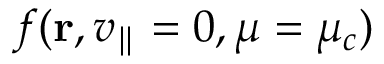<formula> <loc_0><loc_0><loc_500><loc_500>f ( r , v _ { \| } = 0 , \mu = \mu _ { c } )</formula> 